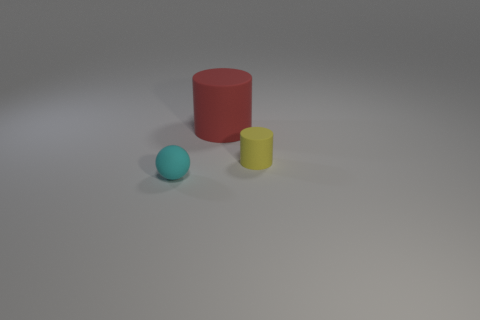Is there anything else that is the same size as the red cylinder?
Make the answer very short. No. What number of big blue rubber spheres are there?
Keep it short and to the point. 0. There is a matte object that is in front of the yellow matte cylinder; is its size the same as the rubber object on the right side of the big red matte object?
Ensure brevity in your answer.  Yes. What color is the large matte object that is the same shape as the small yellow matte object?
Make the answer very short. Red. Does the tiny cyan thing have the same shape as the small yellow rubber object?
Provide a short and direct response. No. What is the size of the yellow thing that is the same shape as the red object?
Give a very brief answer. Small. What number of tiny yellow cylinders are the same material as the big thing?
Keep it short and to the point. 1. How many things are large things or small cylinders?
Give a very brief answer. 2. Is there a tiny yellow rubber cylinder that is behind the tiny object right of the big matte object?
Keep it short and to the point. No. Is the number of matte objects that are behind the cyan ball greater than the number of large matte objects that are left of the big red matte thing?
Make the answer very short. Yes. 